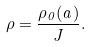Convert formula to latex. <formula><loc_0><loc_0><loc_500><loc_500>\rho = \frac { \rho _ { 0 } ( { a } ) } { J } .</formula> 